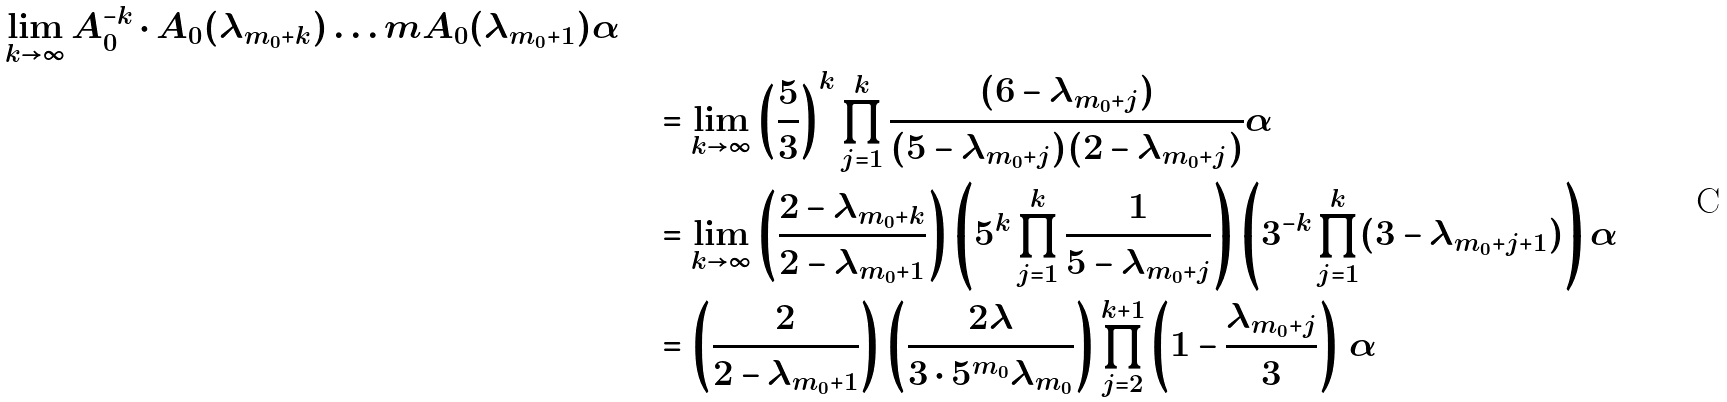<formula> <loc_0><loc_0><loc_500><loc_500>{ \lim _ { k \rightarrow \infty } A _ { 0 } ^ { - k } \cdot A _ { 0 } ( \lambda _ { m _ { 0 } + k } ) \dots m A _ { 0 } ( \lambda _ { m _ { 0 } + 1 } ) \alpha } \quad & \\ & = \lim _ { k \rightarrow \infty } \left ( \frac { 5 } { 3 } \right ) ^ { k } \prod _ { j = 1 } ^ { k } \frac { ( 6 - \lambda _ { m _ { 0 } + j } ) } { ( 5 - \lambda _ { m _ { 0 } + j } ) ( 2 - \lambda _ { m _ { 0 } + j } ) } \alpha \\ & = \lim _ { k \rightarrow \infty } \left ( \frac { 2 - \lambda _ { m _ { 0 } + k } } { 2 - \lambda _ { m _ { 0 } + 1 } } \right ) \left ( 5 ^ { k } \prod _ { j = 1 } ^ { k } \frac { 1 } { 5 - \lambda _ { m _ { 0 } + j } } \right ) \left ( 3 ^ { - k } \prod _ { j = 1 } ^ { k } ( 3 - \lambda _ { m _ { 0 } + j + 1 } ) \right ) \alpha \\ & = \left ( \frac { 2 } { 2 - \lambda _ { m _ { 0 } + 1 } } \right ) \left ( \frac { 2 \lambda } { 3 \cdot 5 ^ { m _ { 0 } } \lambda _ { m _ { 0 } } } \right ) \prod _ { j = 2 } ^ { k + 1 } \left ( 1 - \frac { \lambda _ { m _ { 0 } + j } } { 3 } \right ) \, \alpha</formula> 